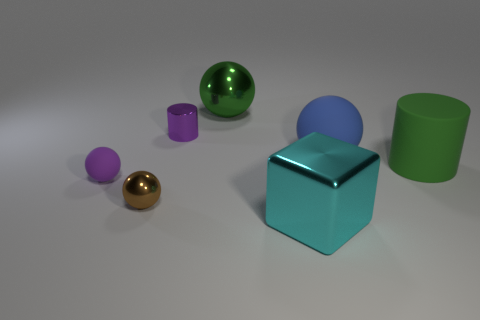The thing that is the same color as the tiny matte sphere is what size?
Provide a short and direct response. Small. The tiny shiny thing that is the same color as the tiny matte object is what shape?
Keep it short and to the point. Cylinder. How big is the shiny sphere in front of the matte ball that is on the right side of the big thing in front of the brown ball?
Make the answer very short. Small. What number of other things are the same material as the large blue ball?
Ensure brevity in your answer.  2. What size is the object behind the purple metallic object?
Your response must be concise. Large. What number of objects are both behind the tiny brown shiny thing and to the right of the purple matte thing?
Your response must be concise. 4. What material is the large ball in front of the cylinder left of the big green shiny ball?
Make the answer very short. Rubber. There is a large green object that is the same shape as the brown object; what is it made of?
Ensure brevity in your answer.  Metal. Are any large gray matte cylinders visible?
Keep it short and to the point. No. What is the shape of the cyan thing that is made of the same material as the green sphere?
Offer a very short reply. Cube. 